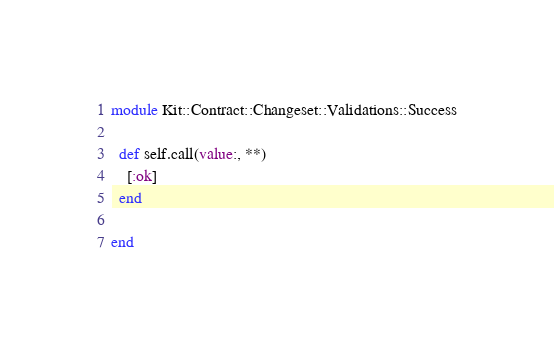<code> <loc_0><loc_0><loc_500><loc_500><_Ruby_>module Kit::Contract::Changeset::Validations::Success

  def self.call(value:, **)
    [:ok]
  end

end
</code> 